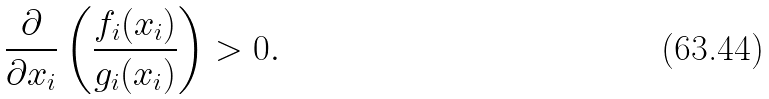Convert formula to latex. <formula><loc_0><loc_0><loc_500><loc_500>\frac { \partial } { \partial x _ { i } } \left ( \frac { f _ { i } ( x _ { i } ) } { g _ { i } ( x _ { i } ) } \right ) > 0 .</formula> 